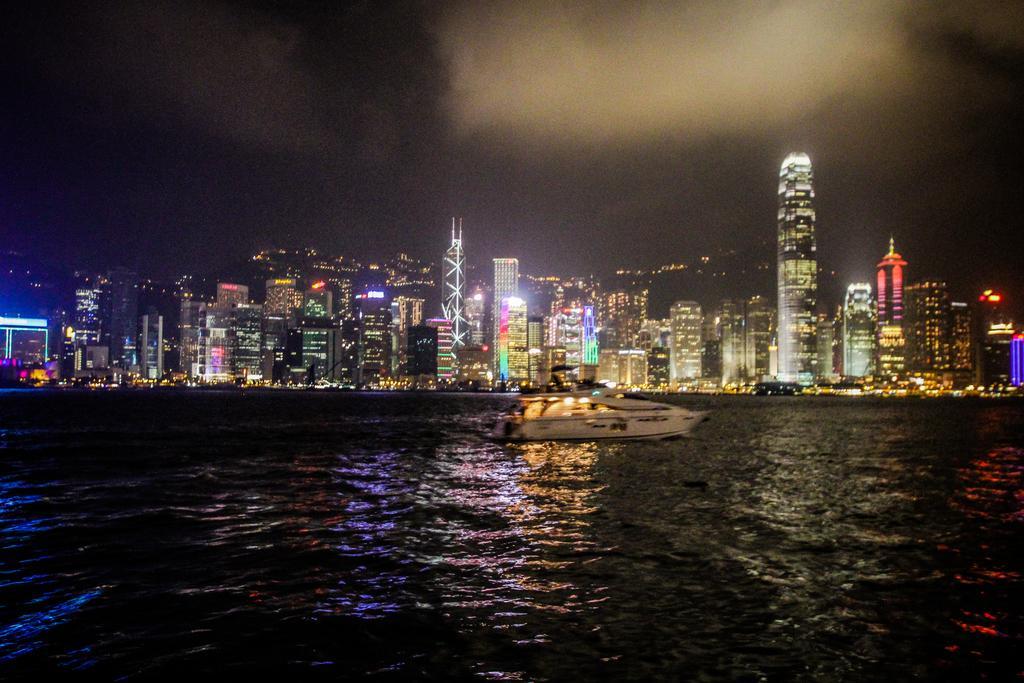Describe this image in one or two sentences. This image is taken in night mode. In the background there are many buildings with lightning. At the top there is a sky with clouds. 